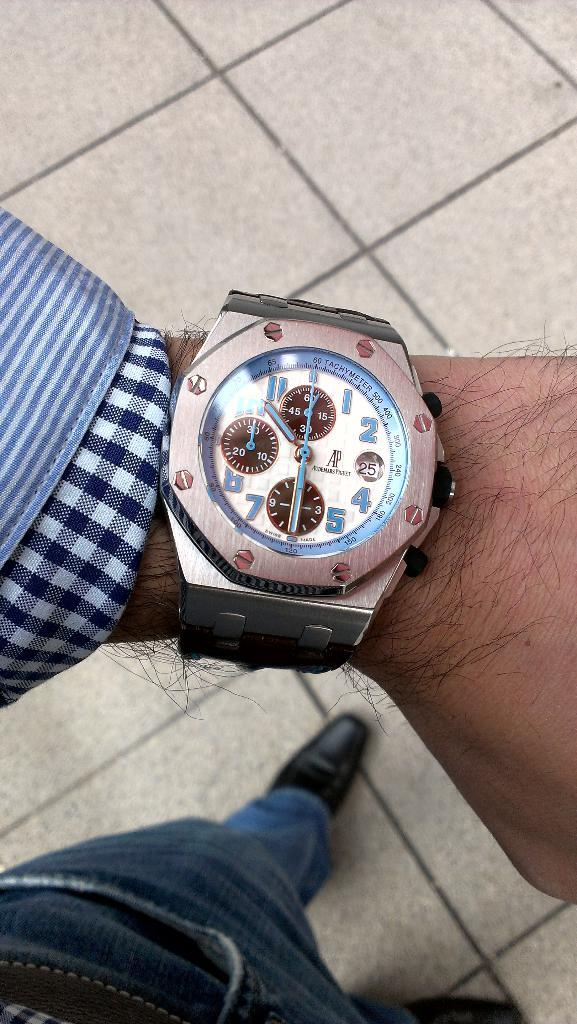<image>
Summarize the visual content of the image. 10 thrity is the time acorrding to the watch. 